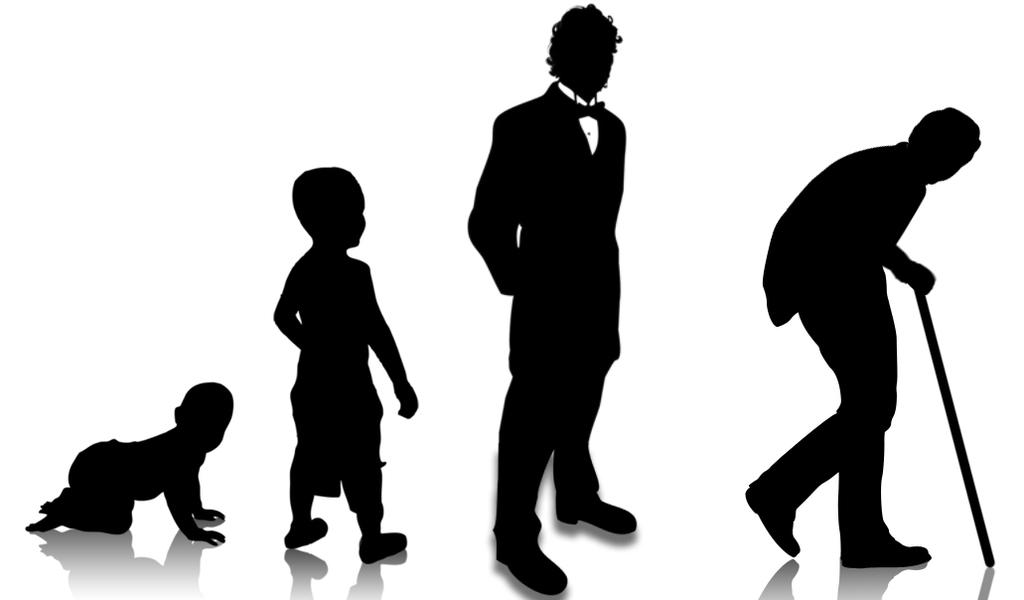What is the main subject of the image? The main subject of the image is an illustration of a man. How is the man depicted in the illustration? The illustration shows the man at different stages of his life. What color is the background of the image? The background of the image is white. How many crates are stacked behind the man in the image? There are no crates present in the image; it only contains an illustration of a man on a white background. 